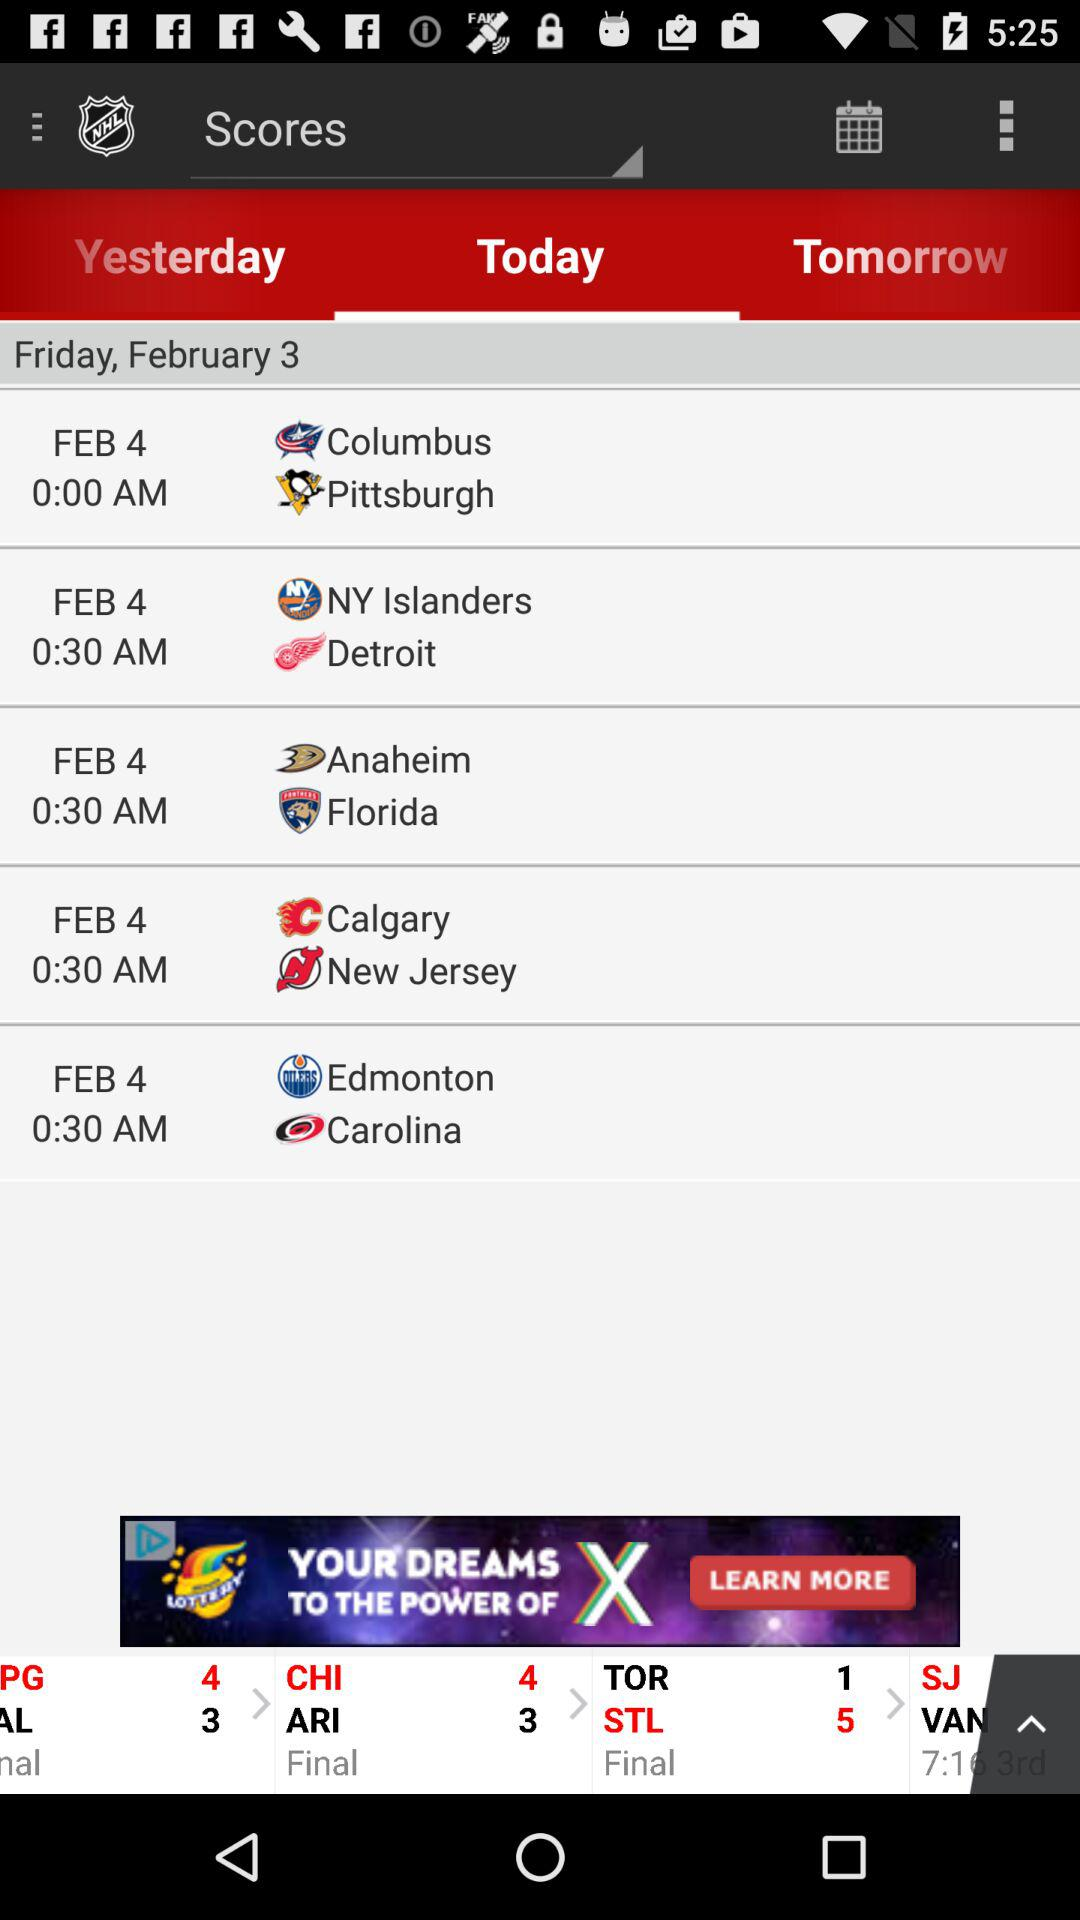What is the final score of ARI? The final score of ARI is 3. 